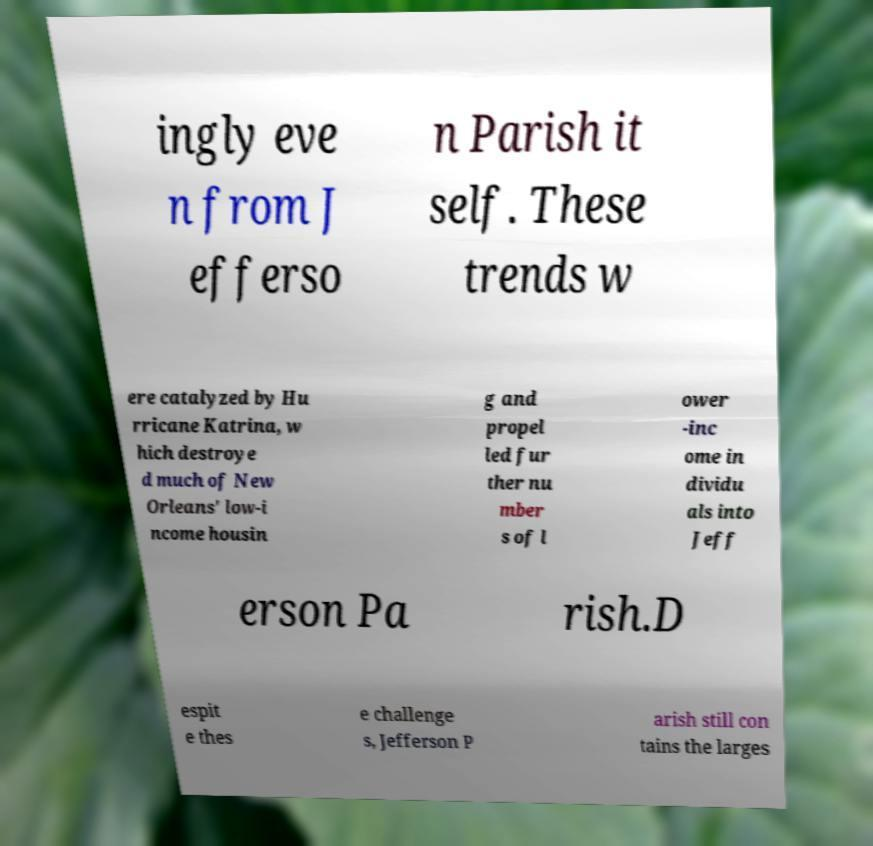Please read and relay the text visible in this image. What does it say? ingly eve n from J efferso n Parish it self. These trends w ere catalyzed by Hu rricane Katrina, w hich destroye d much of New Orleans' low-i ncome housin g and propel led fur ther nu mber s of l ower -inc ome in dividu als into Jeff erson Pa rish.D espit e thes e challenge s, Jefferson P arish still con tains the larges 